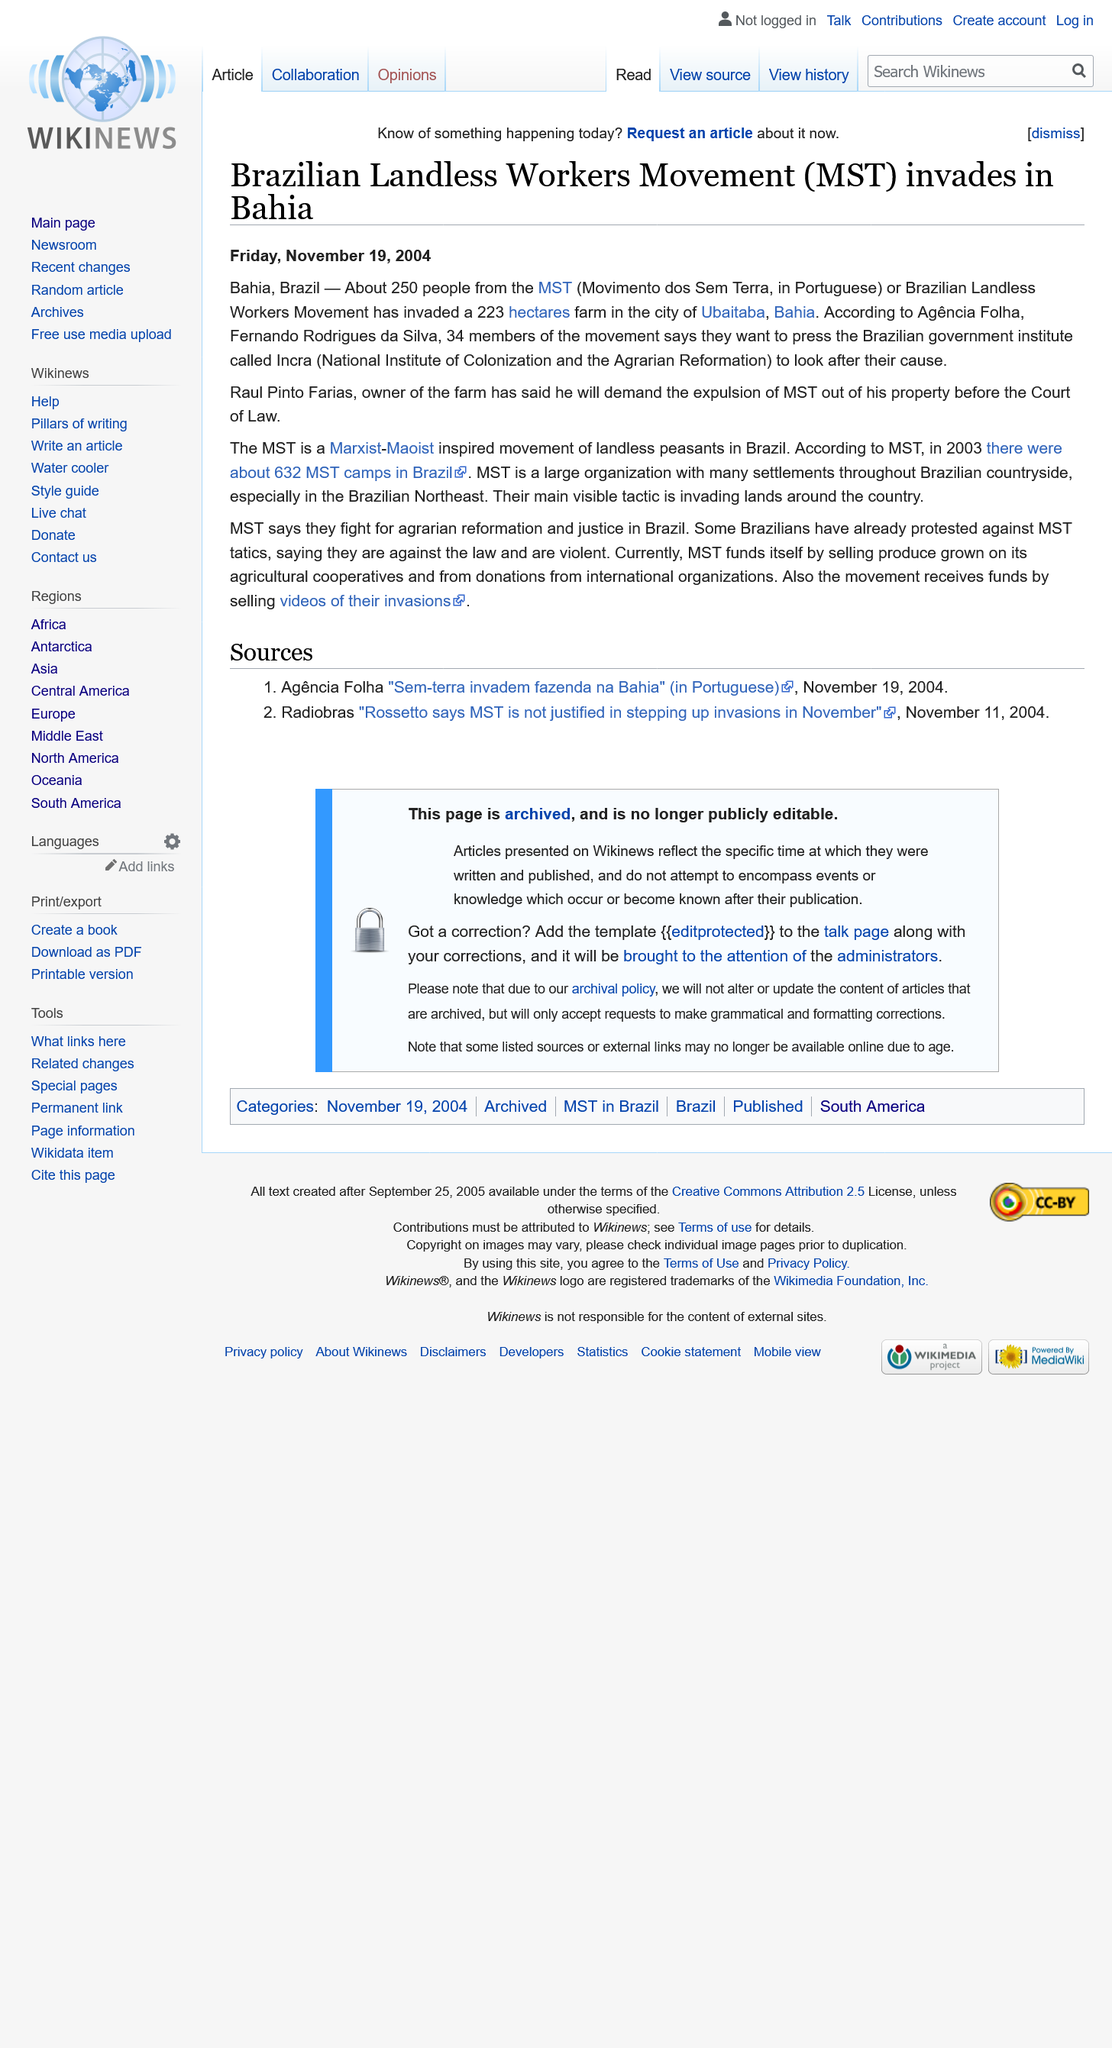List a handful of essential elements in this visual. MST stands for Movimento dos Sem Terra, which is a Portuguese acronym that stands for Landless Workers' Movement. On Friday November 19th 2004, the article was published. In the city of Ubaitaba, Bahia, about 250 people from the MST invaded a farm. 